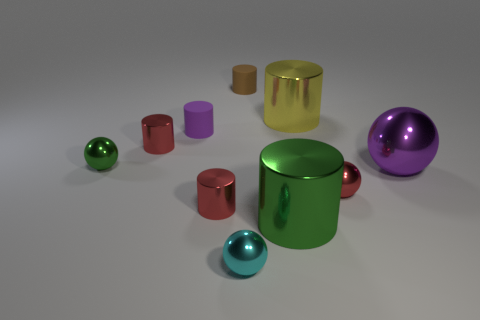How many things are either green cylinders or small spheres that are on the left side of the large green metal cylinder?
Your response must be concise. 3. There is a large metal thing right of the tiny thing to the right of the tiny brown cylinder; what number of large cylinders are in front of it?
Your answer should be compact. 1. There is a tiny cylinder that is the same color as the large metal sphere; what material is it?
Provide a succinct answer. Rubber. What number of large cyan rubber objects are there?
Your response must be concise. 0. There is a rubber thing that is to the left of the brown cylinder; is its size the same as the green shiny sphere?
Keep it short and to the point. Yes. What number of shiny objects are either small purple cubes or large yellow objects?
Your answer should be very brief. 1. There is a tiny red metallic ball that is on the left side of the purple shiny ball; what number of yellow objects are in front of it?
Give a very brief answer. 0. The big thing that is both in front of the large yellow object and behind the red ball has what shape?
Your answer should be very brief. Sphere. What material is the tiny object that is behind the purple thing that is behind the red thing behind the small red shiny sphere?
Ensure brevity in your answer.  Rubber. What is the size of the cylinder that is the same color as the large shiny sphere?
Keep it short and to the point. Small. 